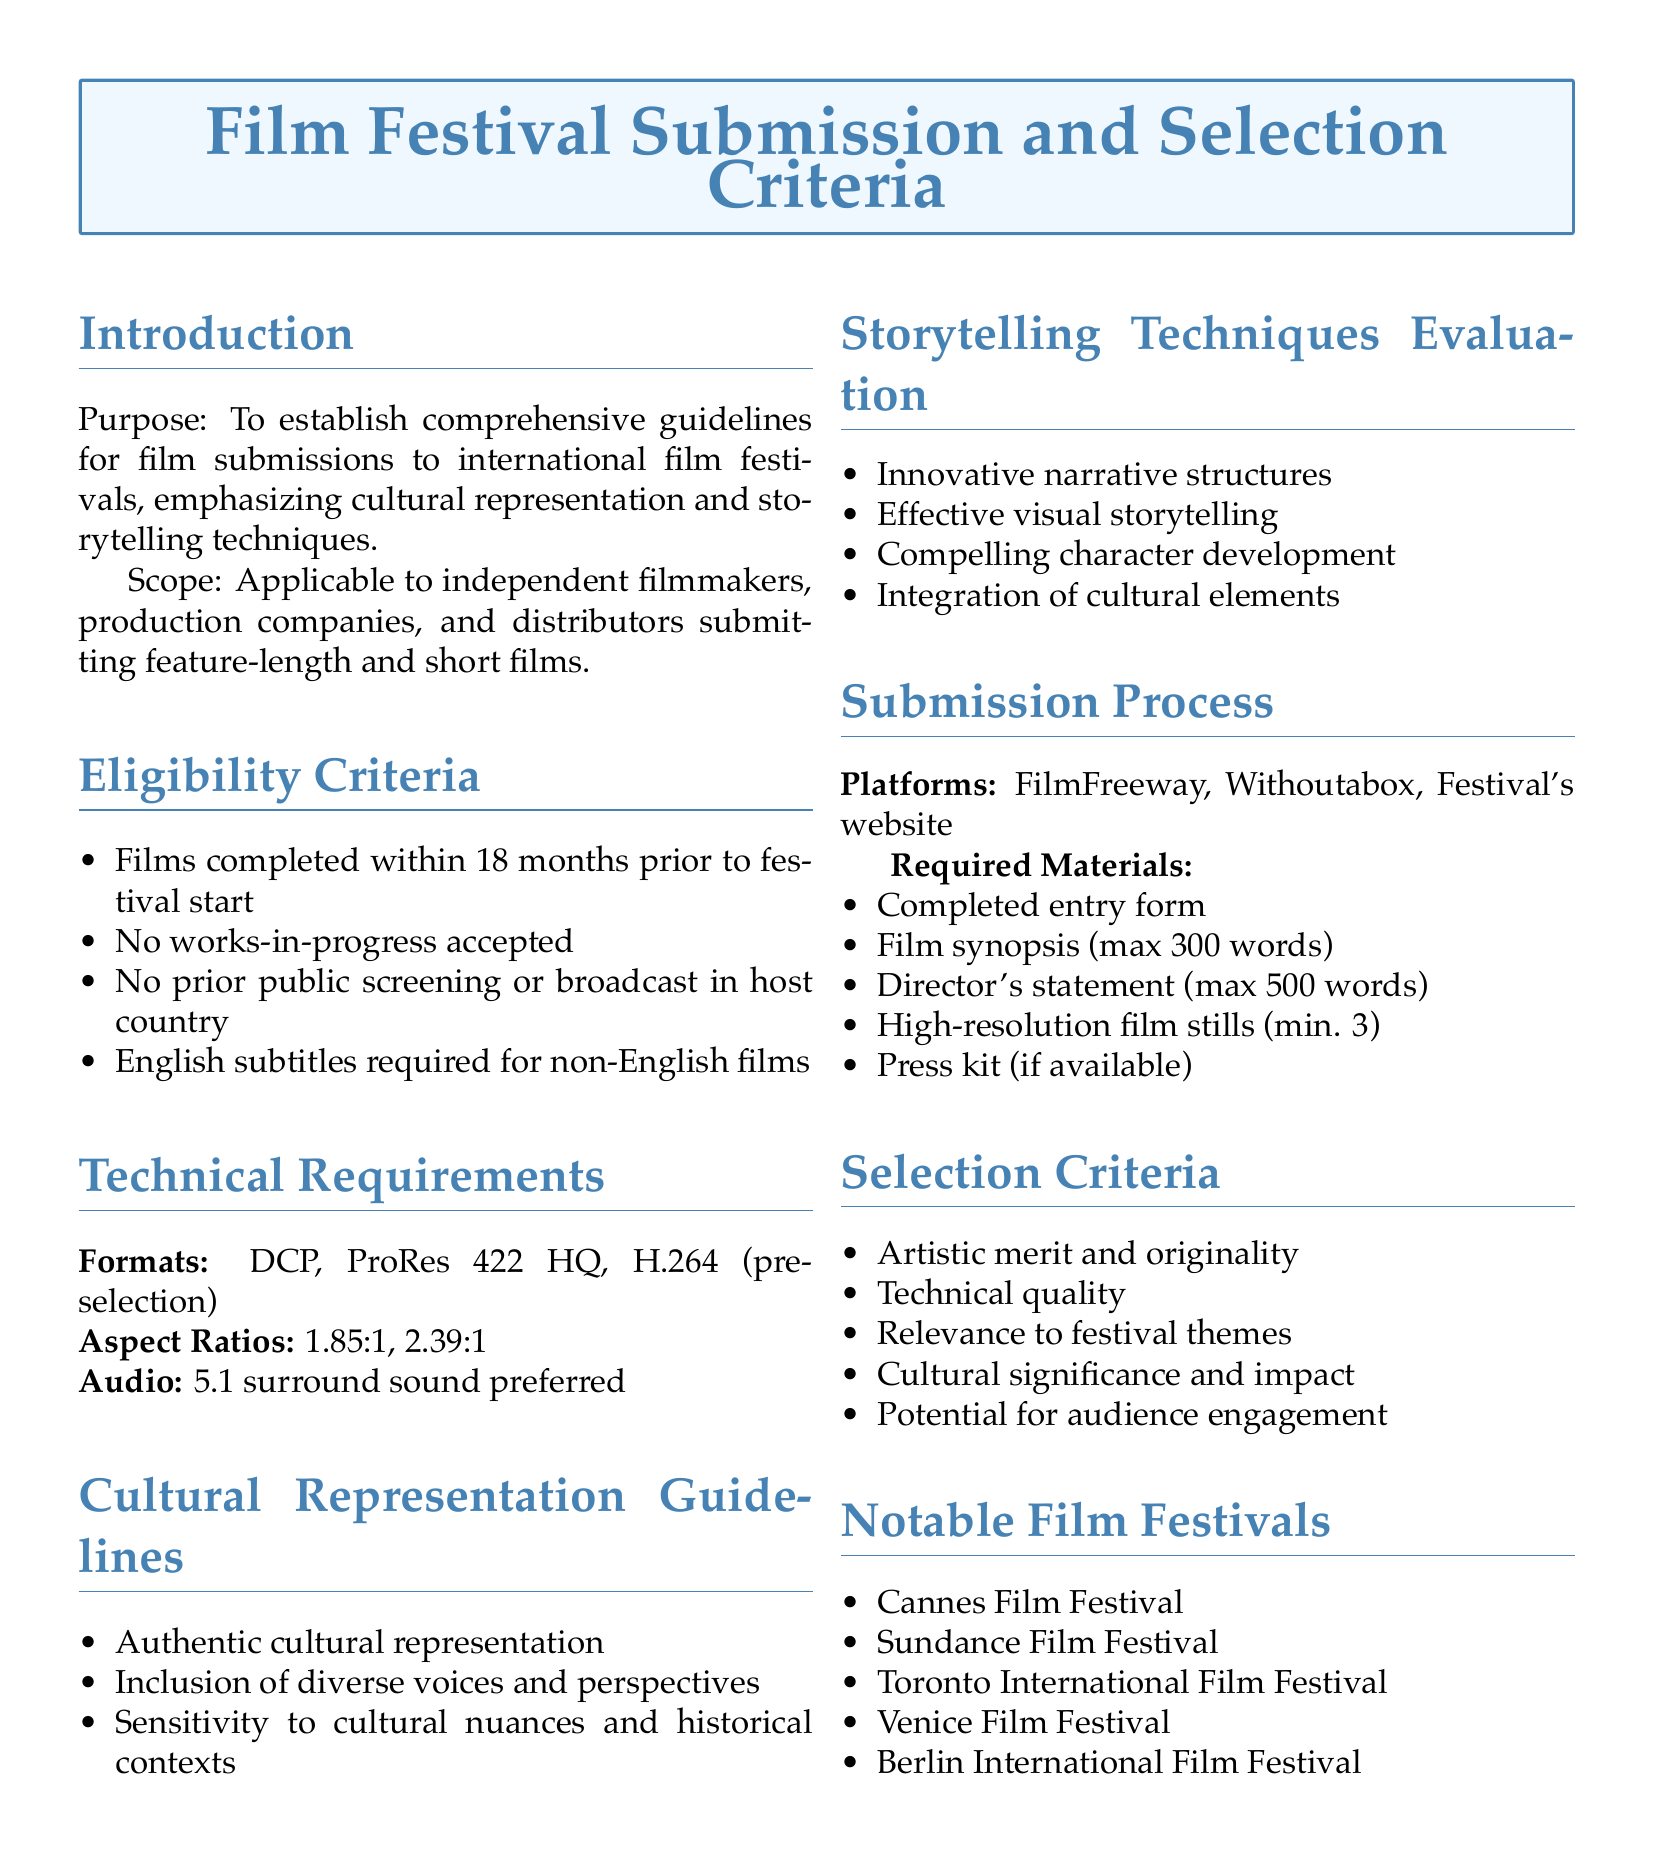What is the purpose of the document? The purpose of the document is to establish comprehensive guidelines for film submissions to international film festivals, emphasizing cultural representation and storytelling techniques.
Answer: To establish comprehensive guidelines for film submissions to international film festivals, emphasizing cultural representation and storytelling techniques What is a requirement for non-English films? The requirement for non-English films is that they must have English subtitles.
Answer: English subtitles required for non-English films What audio format is preferred? The preferred audio format mentioned in the document is 5.1 surround sound.
Answer: 5.1 surround sound preferred How many words are allowed in the film synopsis? The maximum word count for the film synopsis is specified in the document.
Answer: max 300 words What are two components evaluated in storytelling techniques? The components evaluated include effective visual storytelling and compelling character development.
Answer: Effective visual storytelling, compelling character development What kind of festivals are listed in the document? The document lists notable international film festivals.
Answer: Notable international film festivals Which online platforms can submissions be made through? Submissions can be made through FilmFreeway, Withoutabox, and the Festival's website.
Answer: FilmFreeway, Withoutabox, Festival's website What is a criterion for selection based on storytelling? A criterion for selection based on storytelling is the integration of cultural elements.
Answer: Integration of cultural elements What is one aspect of cultural representation that filmmakers should consider? Filmmakers should consider authentic cultural representation.
Answer: Authentic cultural representation 